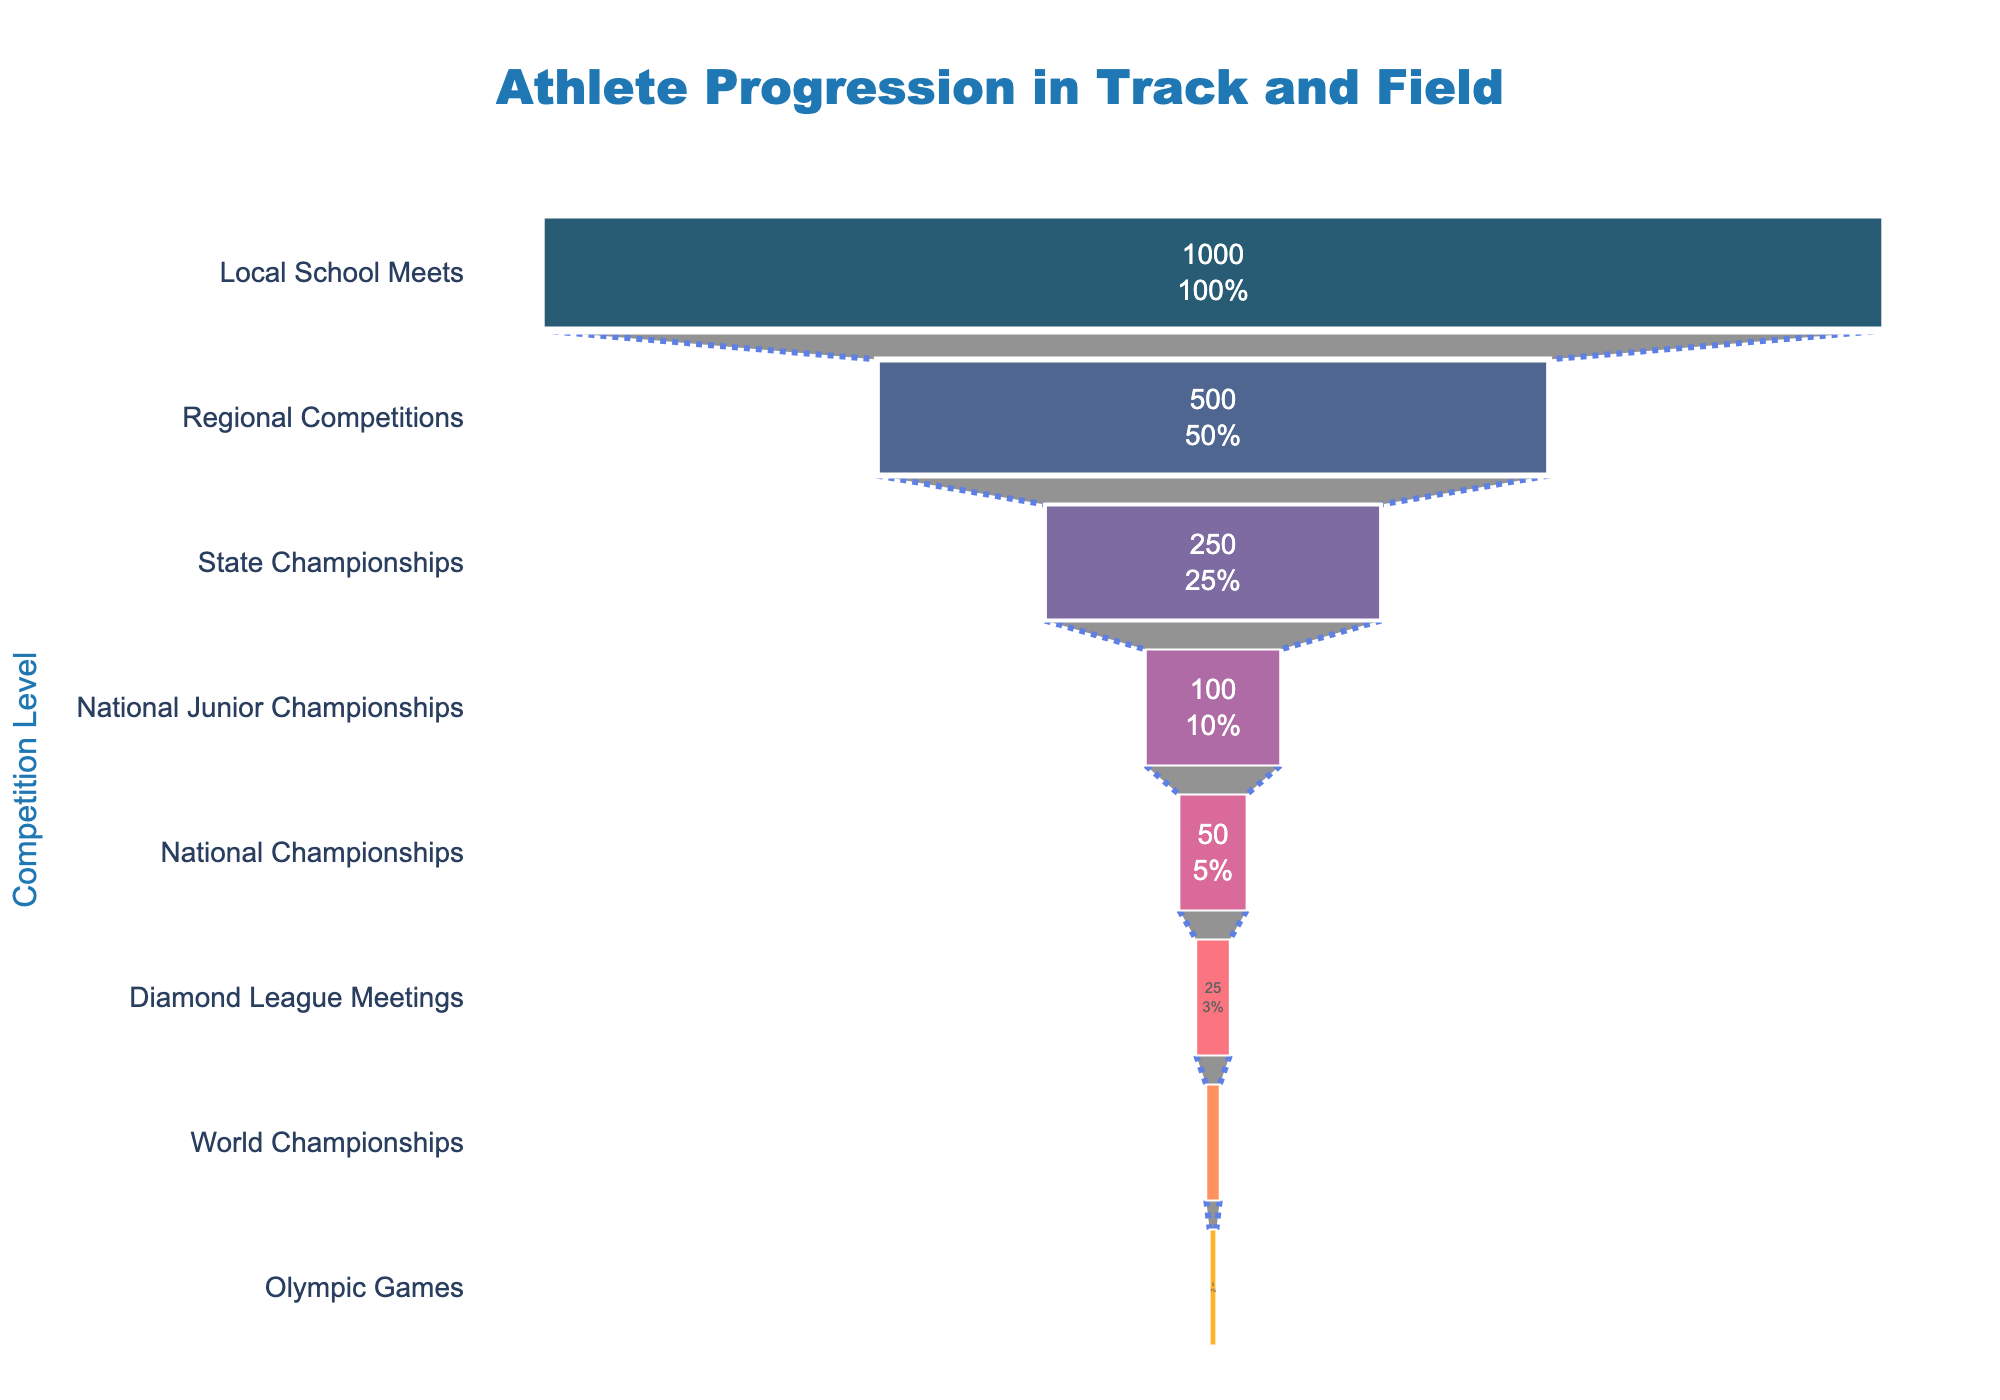what is the title of the funnel chart? Look at the top of the figure, the title should be displayed prominently.
Answer: Athlete Progression in Track and Field how many stages are shown in the funnel chart? Count the number of unique stages listed on the y-axis.
Answer: 8 how many athletes reach the national championships? Refer to the value displayed inside the funnel segment for the 'National Championships' stage.
Answer: 50 what is the percentage of athletes progressing to diamond league meetings from national championships? Identify the initial number of athletes at 'National Championships' and compare it with the count at 'Diamond League Meetings'. The percentage is calculated as (Number of Athletes at Diamond League Meetings / Number of Athletes at National Championships) * 100, i.e., (25 / 50) * 100.
Answer: 50% which stage has the largest decrease in the number of athletes compared to its previous stage? Compare the decrease in the number of athletes between consecutive stages and identify the one with the maximum difference. The largest decrease is between 'Regional Competitions' (500) and 'Local School Meets' (1000), i.e., 1000 - 500 = 500.
Answer: Local School Meets to Regional Competitions what is the total decrease in the number of athletes from the regional competitions to world championships? Calculate the decrease in the number of athletes from 'Regional Competitions' (500) to 'World Championships' (10) by subtracting the latter from the former, i.e., 500 - 10 = 490.
Answer: 490 how many athletes compete at the state championships compared to the national junior championships? Use the values inside the funnel segments to find the number of athletes at 'State Championships' and 'National Junior Championships', which are 250 and 100, respectively. The comparison is between 250 and 100.
Answer: 250 > 100 what percentage of athletes who started at local school meets end up competing at the olympic games? Use the values for 'Local School Meets' (1000) and 'Olympic Games' (5). The percentage calculation is (Number of Athletes at Olympic Games / Number of Athletes at Local School Meets) * 100, i.e., (5 / 1000) * 100.
Answer: 0.5% what is the percentage retained at the state championships stage from the previous regional competitions stage? Compare the number of athletes at 'State Championships' (250) to 'Regional Competitions' (500) and perform the calculation: (Number of Athletes at State Championships / Number of Athletes at Regional Competitions) *100, i.e., (250 / 500) * 100.
Answer: 50% 